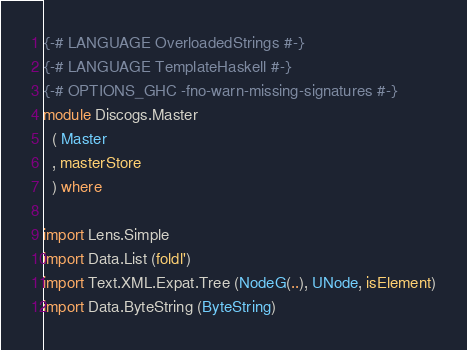<code> <loc_0><loc_0><loc_500><loc_500><_Haskell_>{-# LANGUAGE OverloadedStrings #-}
{-# LANGUAGE TemplateHaskell #-}
{-# OPTIONS_GHC -fno-warn-missing-signatures #-}
module Discogs.Master
  ( Master
  , masterStore
  ) where

import Lens.Simple
import Data.List (foldl')
import Text.XML.Expat.Tree (NodeG(..), UNode, isElement)
import Data.ByteString (ByteString)
</code> 